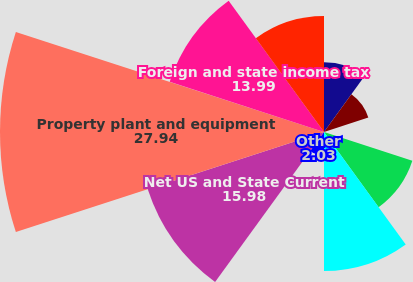<chart> <loc_0><loc_0><loc_500><loc_500><pie_chart><fcel>(in thousands)<fcel>Accrued expenses<fcel>Deferred income<fcel>Allowance for doubtful<fcel>Fair value of derivative<fcel>Other<fcel>Net US and State Current<fcel>Property plant and equipment<fcel>Foreign and state income tax<fcel>Postretirement benefits<nl><fcel>6.01%<fcel>4.02%<fcel>0.03%<fcel>8.01%<fcel>11.99%<fcel>2.03%<fcel>15.98%<fcel>27.94%<fcel>13.99%<fcel>10.0%<nl></chart> 